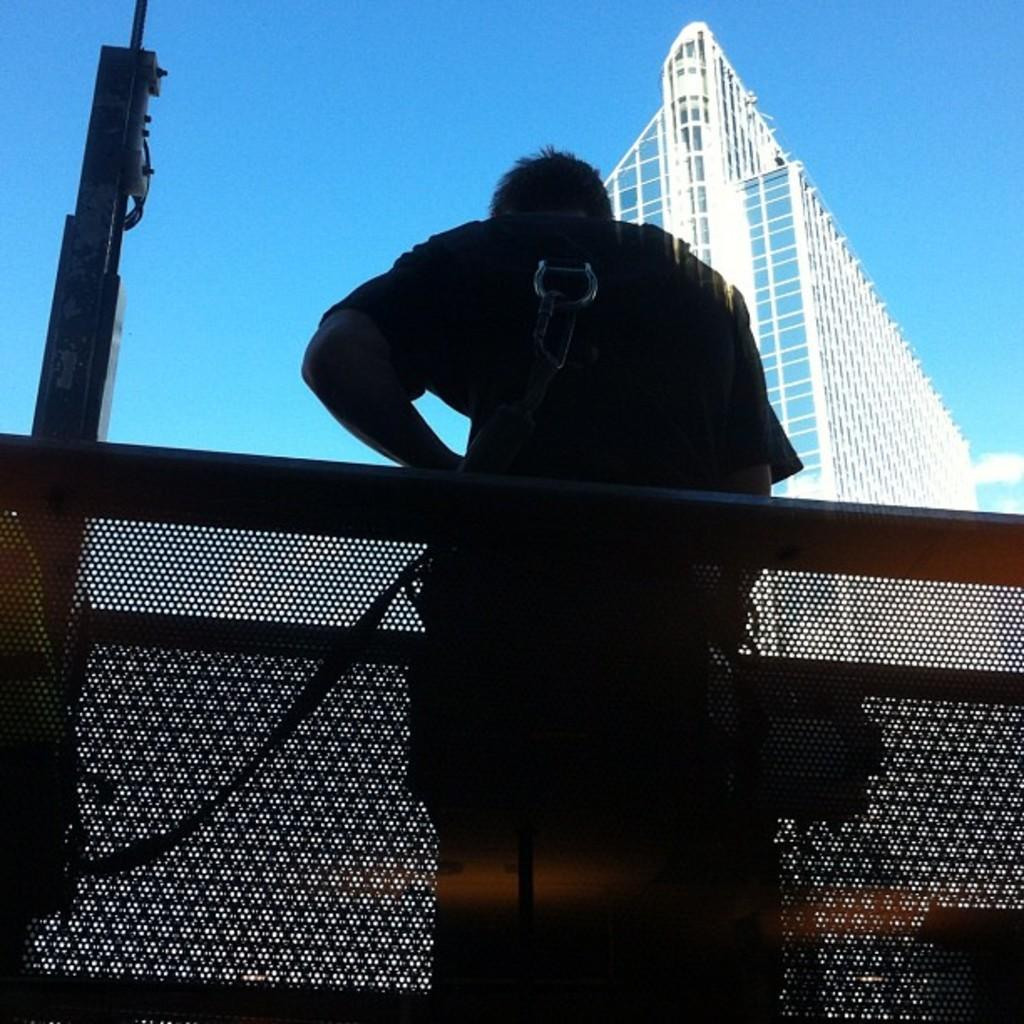What is the main subject in the image? There is a person in the image. What can be seen in the background of the image? There is a fence, a building, and a pole in the image. Are there any other objects visible in the image? Yes, there are some objects in the image. What is visible in the sky in the image? The sky is visible in the image, and clouds are present in the sky. How many fish can be seen swimming in the image? There are no fish present in the image. What type of plant is growing near the person in the image? There is no plant visible in the image. 